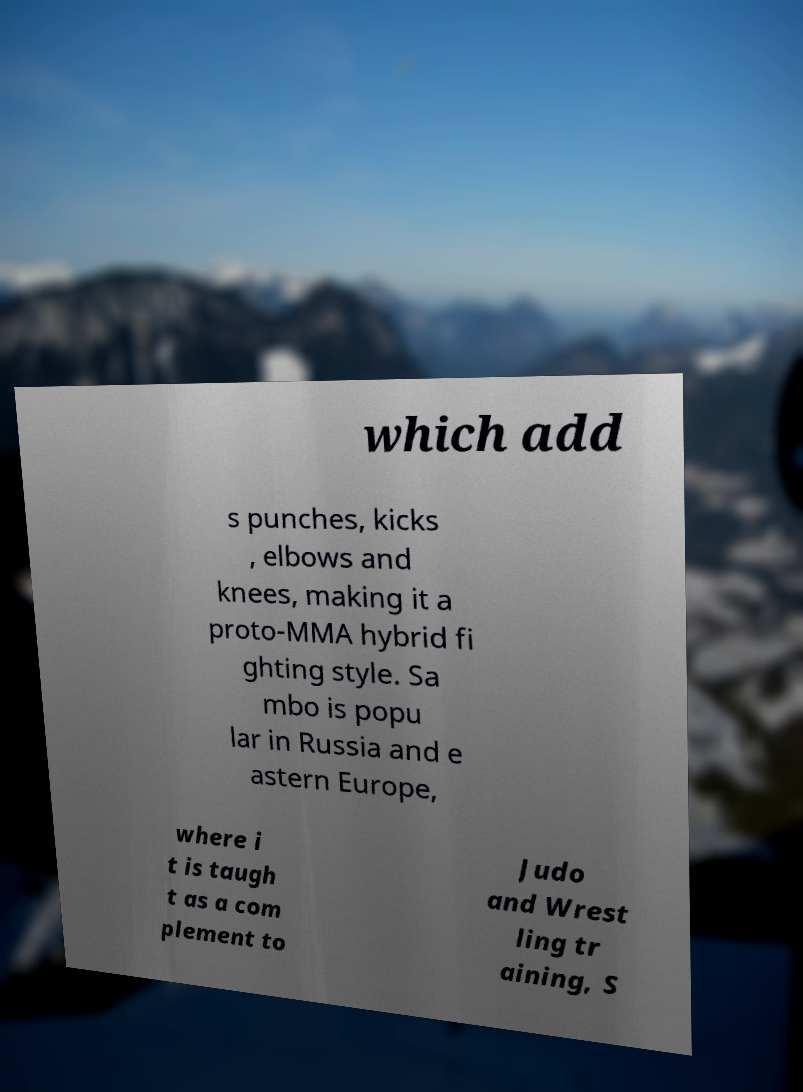What messages or text are displayed in this image? I need them in a readable, typed format. which add s punches, kicks , elbows and knees, making it a proto-MMA hybrid fi ghting style. Sa mbo is popu lar in Russia and e astern Europe, where i t is taugh t as a com plement to Judo and Wrest ling tr aining, S 